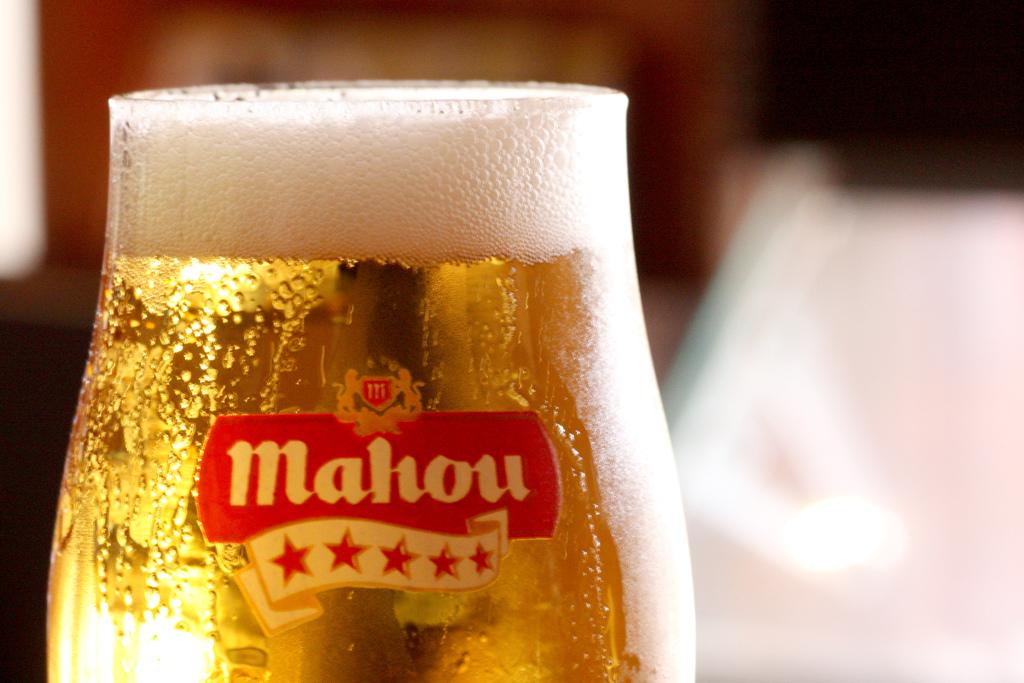What kind of beer is this?
Offer a terse response. Mahou. 